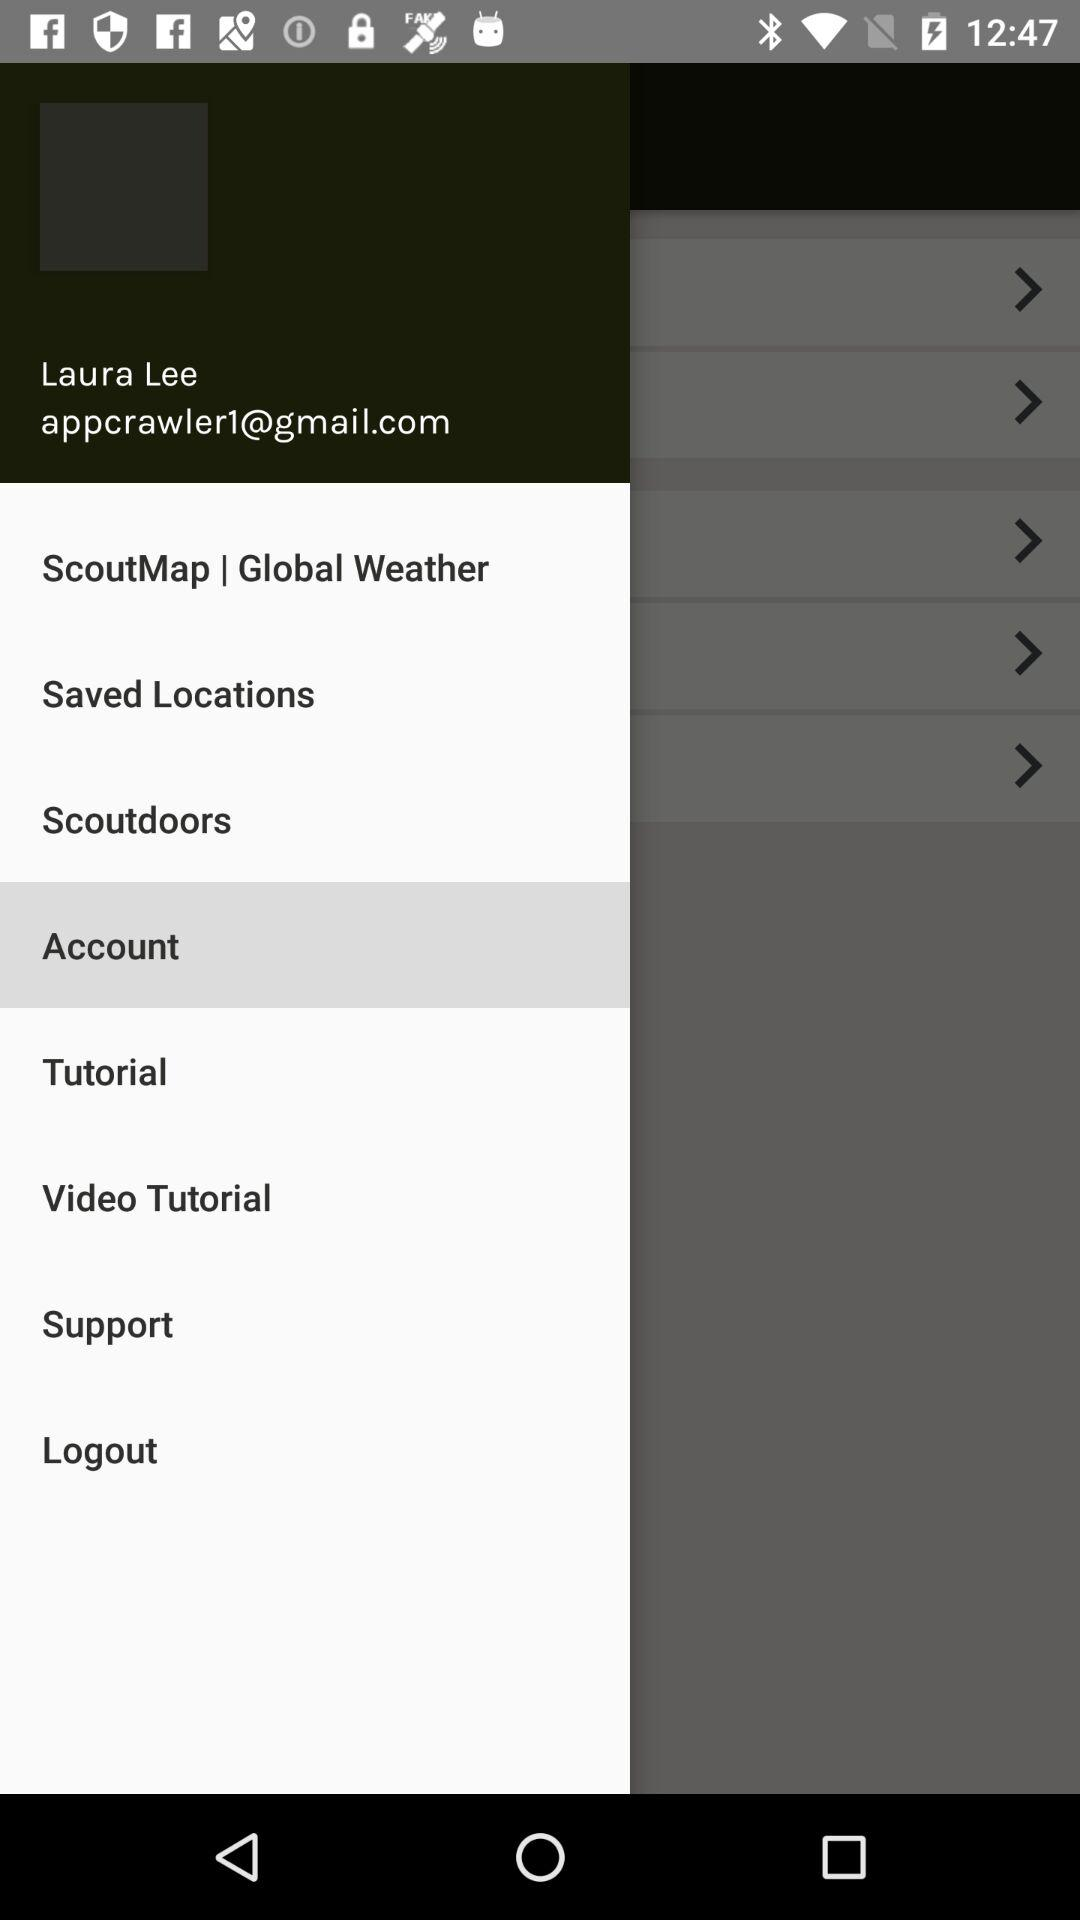What is the profile name? The profile name is Laura Lee. 